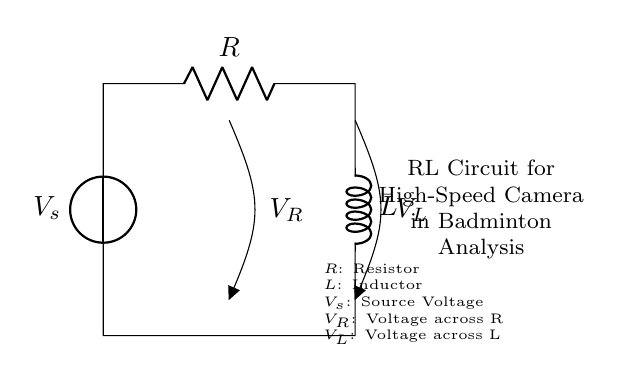What components are present in this circuit? The circuit contains a voltage source, a resistor, and an inductor. These components are essential for the RL circuit configuration.
Answer: voltage source, resistor, inductor What is the purpose of the resistor in this circuit? The resistor limits the current flow in the circuit, reducing the voltage across it according to Ohm's law. This is important for controlling the energy dissipated as heat.
Answer: limit current flow What is the voltage across the resistor denoted as? The voltage across the resistor is labeled as V_R, indicating the potential difference specifically across that component in the circuit.
Answer: V_R How does the voltage across the inductor relate to the supply voltage? The voltage across the inductor (V_L) is affected by the supply voltage and the voltage across the resistor (V_R). According to Kirchhoff's voltage law, the supply voltage equals the sum of V_R and V_L.
Answer: V_s = V_R + V_L What type of circuit is this? This is an RL circuit, characteristic for containing a resistor and an inductor, often used for analyzing transient responses in electrical systems.
Answer: RL circuit What happens to the inductor's voltage when the circuit is first energized? When the circuit is first energized, the inductor opposes changes in current, causing a temporary voltage spike across it due to inductive reactance. This is due to the inductor's property of storing energy in a magnetic field.
Answer: voltage spike 